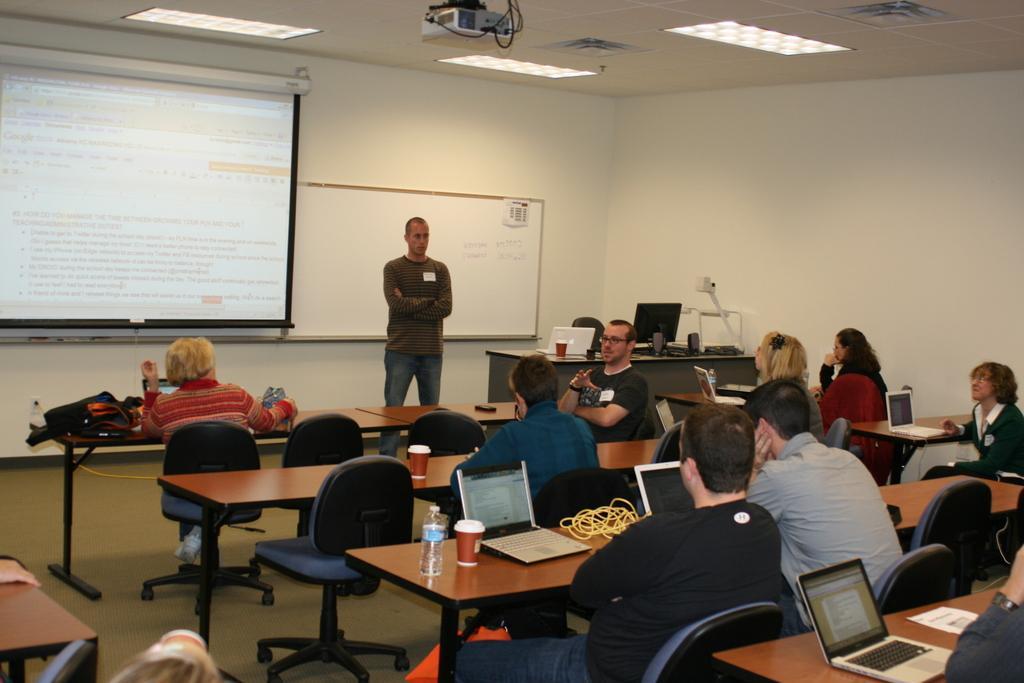How would you summarize this image in a sentence or two? The person wearing black dress is sitting and speaking and there are group of people sitting in chairs and there is a table in front of them which has laptops on it and there is a projected image in the left corner and there is a person standing beside it. 